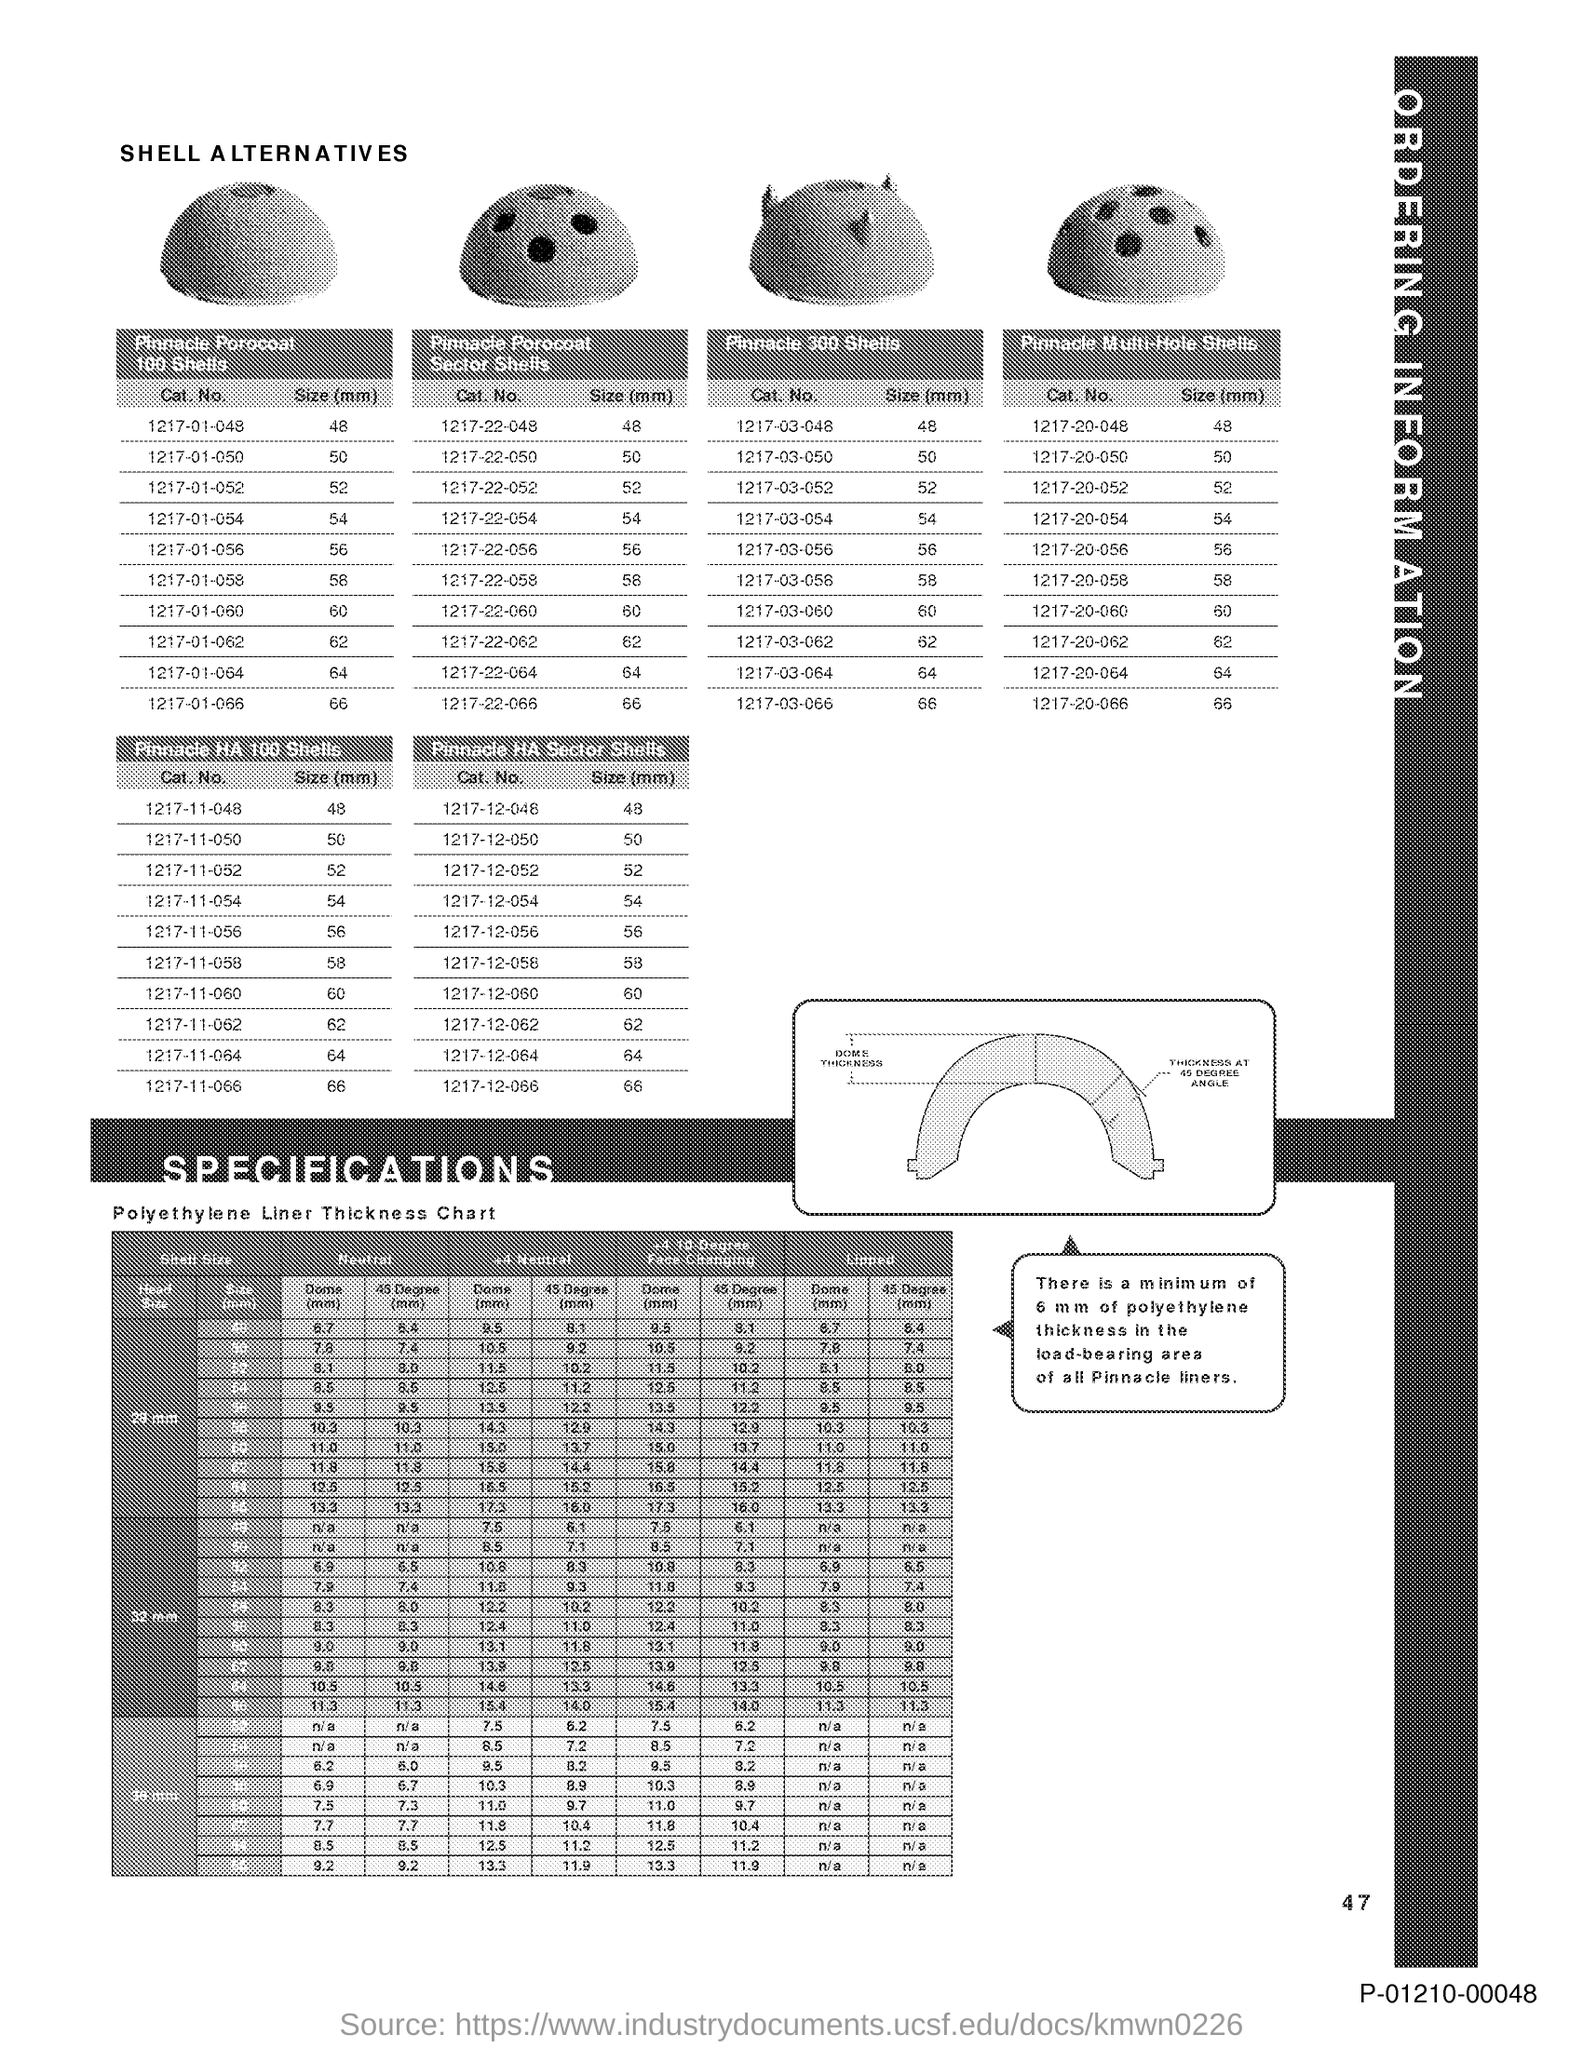Identify some key points in this picture. On page 47, the text states that... 